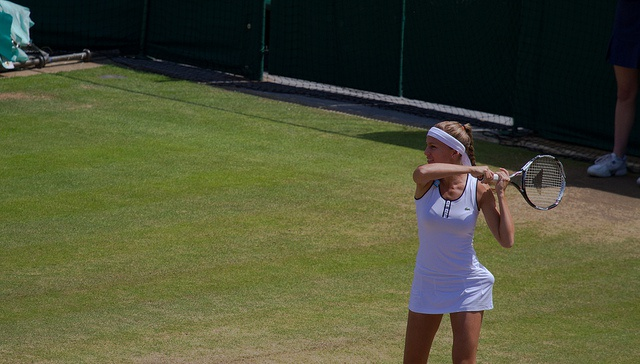Describe the objects in this image and their specific colors. I can see people in lightblue, gray, maroon, and black tones, people in lightblue, black, navy, darkblue, and blue tones, and tennis racket in lightblue, black, gray, and darkgray tones in this image. 